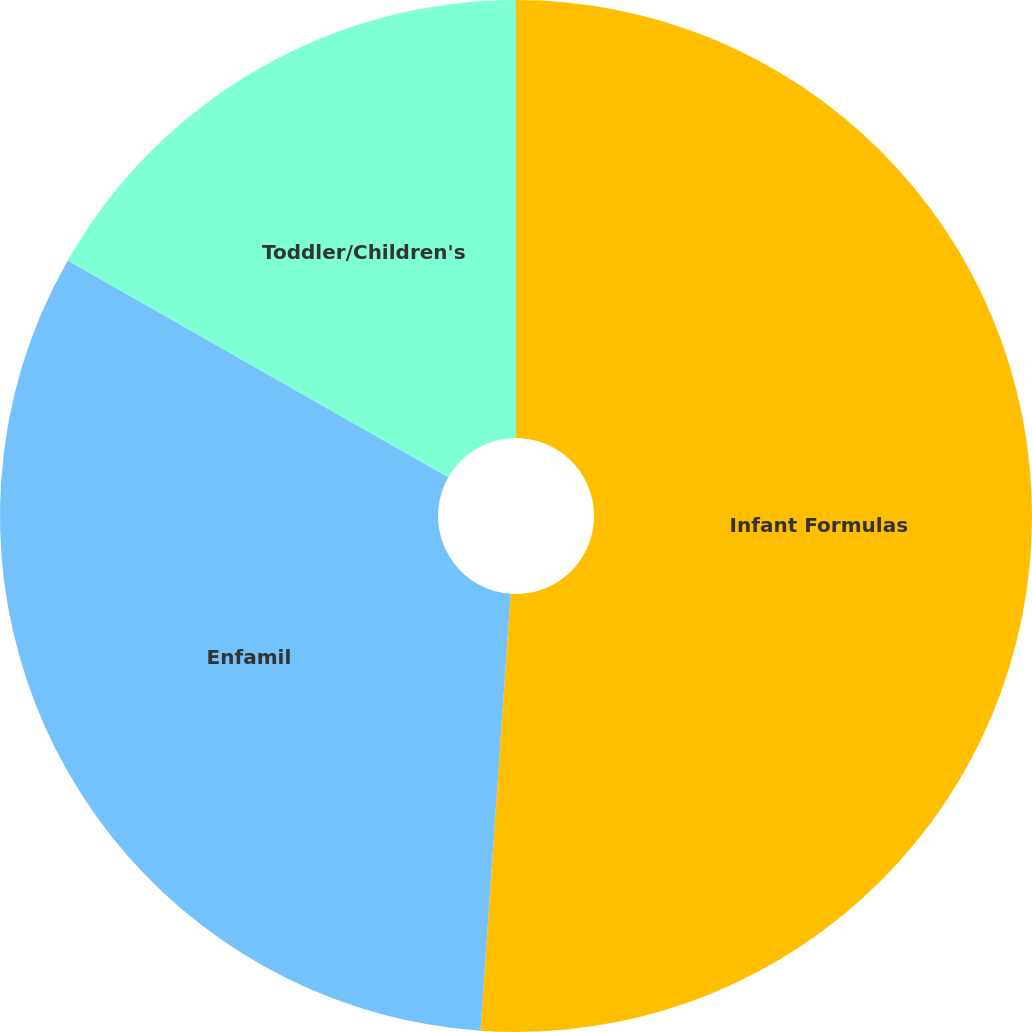Convert chart to OTSL. <chart><loc_0><loc_0><loc_500><loc_500><pie_chart><fcel>Infant Formulas<fcel>Enfamil<fcel>Toddler/Children's<nl><fcel>51.09%<fcel>32.15%<fcel>16.75%<nl></chart> 